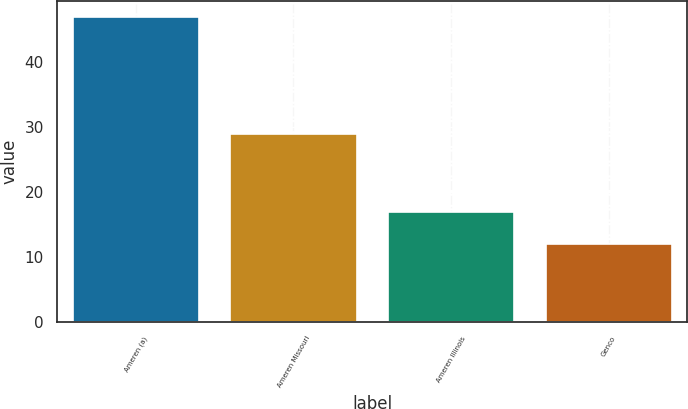Convert chart. <chart><loc_0><loc_0><loc_500><loc_500><bar_chart><fcel>Ameren (a)<fcel>Ameren Missouri<fcel>Ameren Illinois<fcel>Genco<nl><fcel>47<fcel>29<fcel>17<fcel>12<nl></chart> 